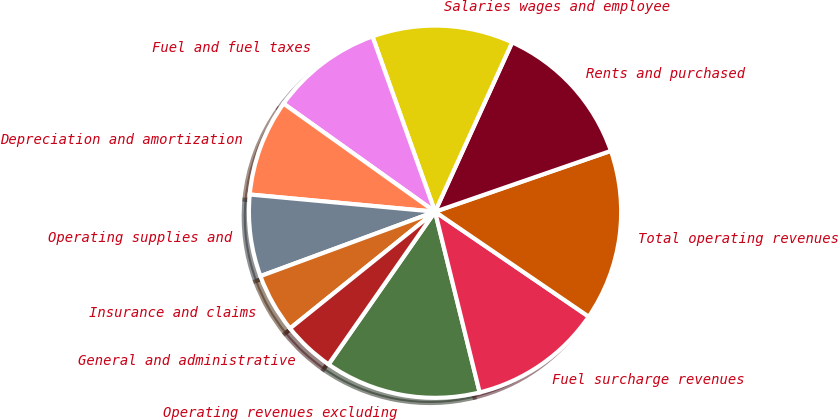Convert chart. <chart><loc_0><loc_0><loc_500><loc_500><pie_chart><fcel>Operating revenues excluding<fcel>Fuel surcharge revenues<fcel>Total operating revenues<fcel>Rents and purchased<fcel>Salaries wages and employee<fcel>Fuel and fuel taxes<fcel>Depreciation and amortization<fcel>Operating supplies and<fcel>Insurance and claims<fcel>General and administrative<nl><fcel>13.55%<fcel>11.61%<fcel>14.84%<fcel>12.9%<fcel>12.26%<fcel>9.68%<fcel>8.39%<fcel>7.1%<fcel>5.16%<fcel>4.52%<nl></chart> 